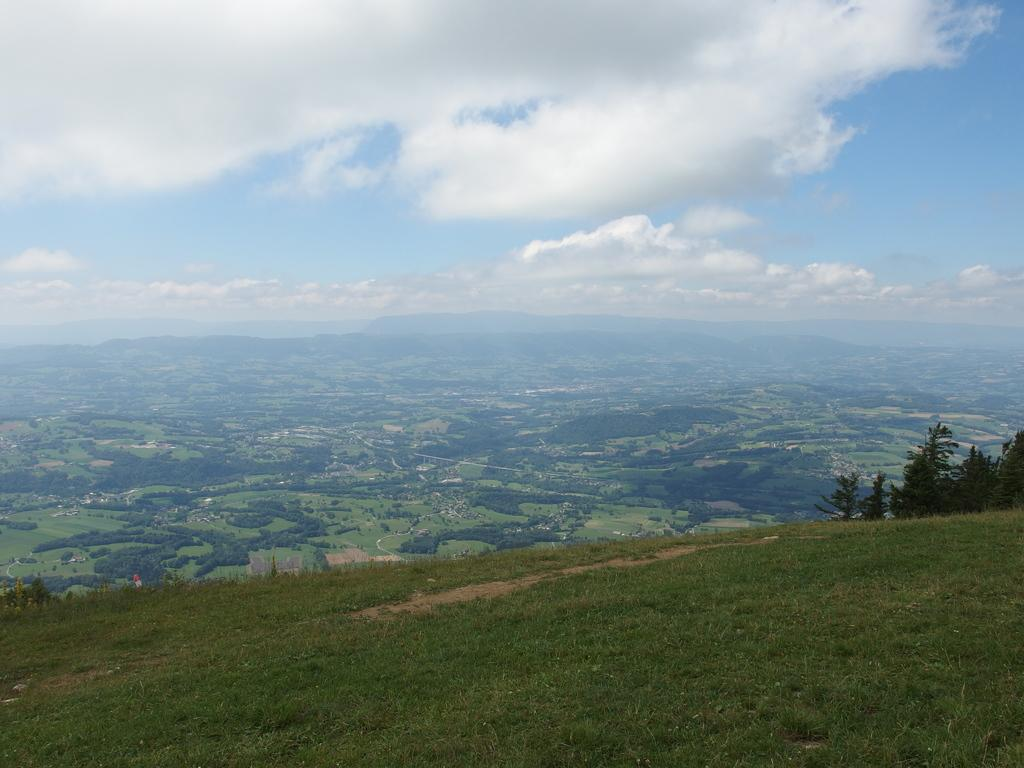What type of landscape is shown in the image? There is a hill view in the image. Can you describe the hill in the image? The hill is visible in the image. What else can be seen in the middle of the image? Some bushes are visible in the middle of the image. What is visible at the top of the image? The sky is visible at the top of the image. What type of vegetation is on the right side of the image? There are plants visible on the right side of the image. What type of drink is being served on the hill in the image? There is no drink visible in the image; it only shows a hill view with bushes, sky, and plants. 